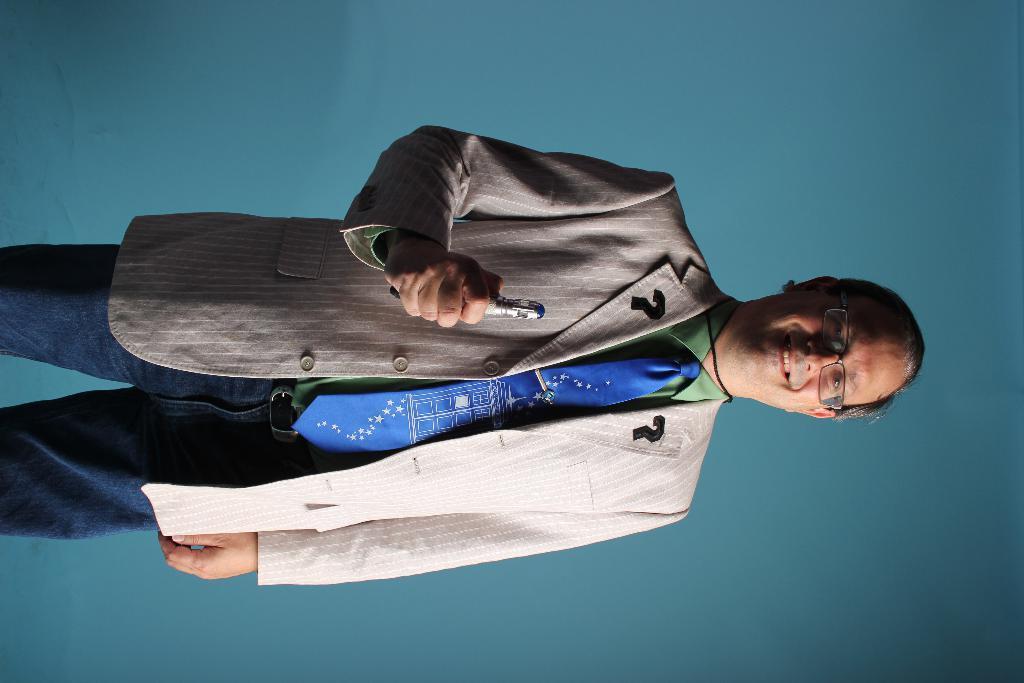How would you summarize this image in a sentence or two? In this image, we can see a man standing, he is wearing a coat and a tie, he is holding a pen, in the background we can see the wall. 